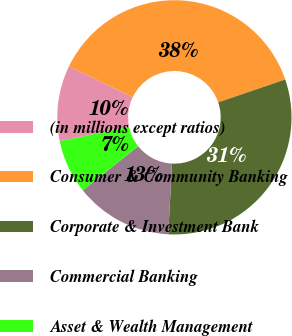Convert chart to OTSL. <chart><loc_0><loc_0><loc_500><loc_500><pie_chart><fcel>(in millions except ratios)<fcel>Consumer & Community Banking<fcel>Corporate & Investment Bank<fcel>Commercial Banking<fcel>Asset & Wealth Management<nl><fcel>10.45%<fcel>37.59%<fcel>31.07%<fcel>13.46%<fcel>7.43%<nl></chart> 